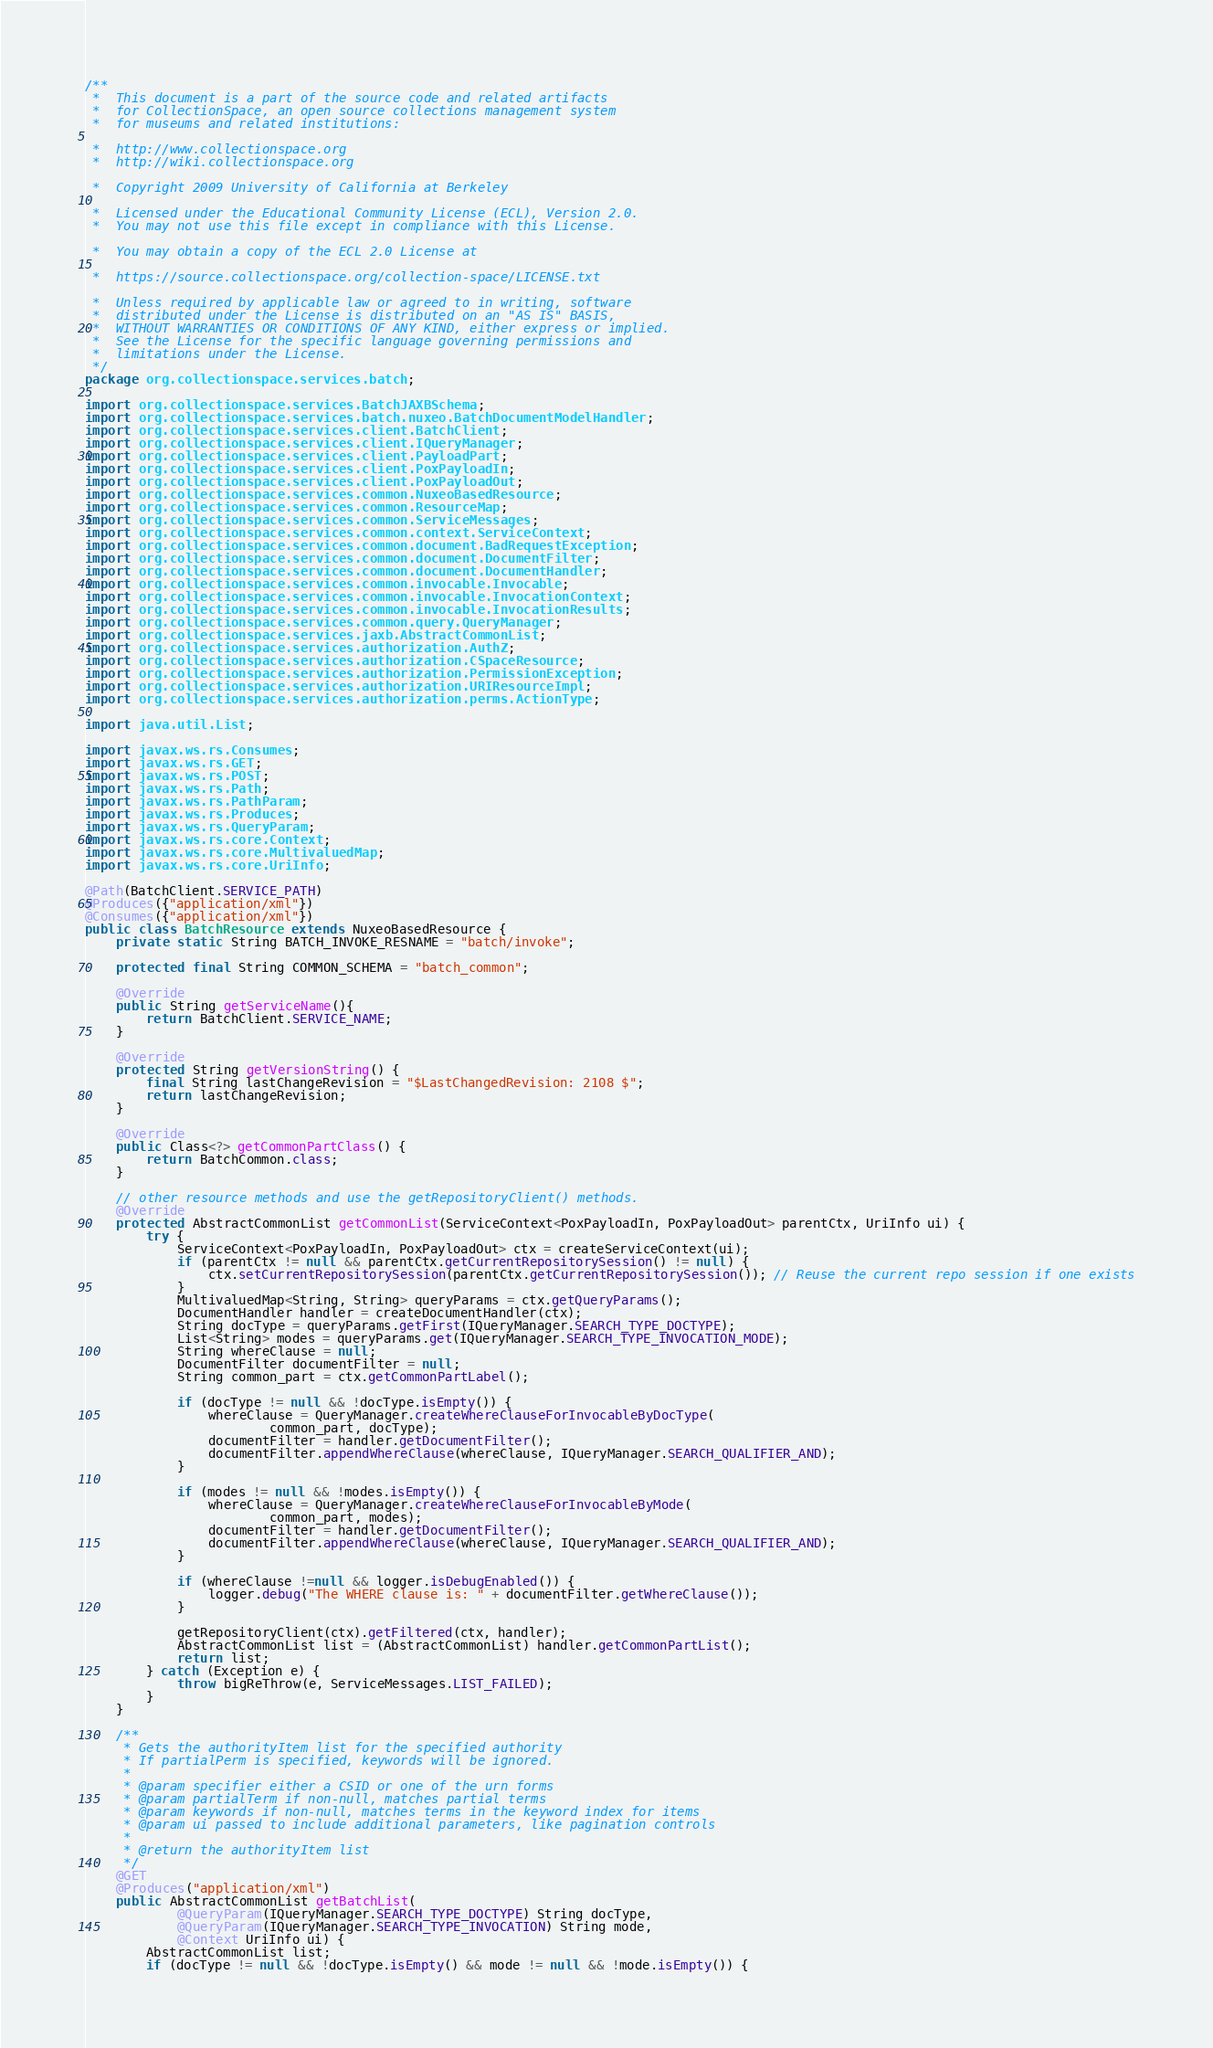Convert code to text. <code><loc_0><loc_0><loc_500><loc_500><_Java_>/**
 *  This document is a part of the source code and related artifacts
 *  for CollectionSpace, an open source collections management system
 *  for museums and related institutions:

 *  http://www.collectionspace.org
 *  http://wiki.collectionspace.org

 *  Copyright 2009 University of California at Berkeley

 *  Licensed under the Educational Community License (ECL), Version 2.0.
 *  You may not use this file except in compliance with this License.

 *  You may obtain a copy of the ECL 2.0 License at

 *  https://source.collectionspace.org/collection-space/LICENSE.txt

 *  Unless required by applicable law or agreed to in writing, software
 *  distributed under the License is distributed on an "AS IS" BASIS,
 *  WITHOUT WARRANTIES OR CONDITIONS OF ANY KIND, either express or implied.
 *  See the License for the specific language governing permissions and
 *  limitations under the License.
 */
package org.collectionspace.services.batch;

import org.collectionspace.services.BatchJAXBSchema;
import org.collectionspace.services.batch.nuxeo.BatchDocumentModelHandler;
import org.collectionspace.services.client.BatchClient;
import org.collectionspace.services.client.IQueryManager;
import org.collectionspace.services.client.PayloadPart;
import org.collectionspace.services.client.PoxPayloadIn;
import org.collectionspace.services.client.PoxPayloadOut;
import org.collectionspace.services.common.NuxeoBasedResource;
import org.collectionspace.services.common.ResourceMap;
import org.collectionspace.services.common.ServiceMessages;
import org.collectionspace.services.common.context.ServiceContext;
import org.collectionspace.services.common.document.BadRequestException;
import org.collectionspace.services.common.document.DocumentFilter;
import org.collectionspace.services.common.document.DocumentHandler;
import org.collectionspace.services.common.invocable.Invocable;
import org.collectionspace.services.common.invocable.InvocationContext;
import org.collectionspace.services.common.invocable.InvocationResults;
import org.collectionspace.services.common.query.QueryManager;
import org.collectionspace.services.jaxb.AbstractCommonList;
import org.collectionspace.services.authorization.AuthZ;
import org.collectionspace.services.authorization.CSpaceResource;
import org.collectionspace.services.authorization.PermissionException;
import org.collectionspace.services.authorization.URIResourceImpl;
import org.collectionspace.services.authorization.perms.ActionType;

import java.util.List;

import javax.ws.rs.Consumes;
import javax.ws.rs.GET;
import javax.ws.rs.POST;
import javax.ws.rs.Path;
import javax.ws.rs.PathParam;
import javax.ws.rs.Produces;
import javax.ws.rs.QueryParam;
import javax.ws.rs.core.Context;
import javax.ws.rs.core.MultivaluedMap;
import javax.ws.rs.core.UriInfo;

@Path(BatchClient.SERVICE_PATH)
@Produces({"application/xml"})
@Consumes({"application/xml"})
public class BatchResource extends NuxeoBasedResource {
    private static String BATCH_INVOKE_RESNAME = "batch/invoke";

	protected final String COMMON_SCHEMA = "batch_common";

    @Override
    public String getServiceName(){
        return BatchClient.SERVICE_NAME;
    }

    @Override
    protected String getVersionString() {
    	final String lastChangeRevision = "$LastChangedRevision: 2108 $";
    	return lastChangeRevision;
    }

    @Override
    public Class<?> getCommonPartClass() {
    	return BatchCommon.class;
    }

	// other resource methods and use the getRepositoryClient() methods.
	@Override
	protected AbstractCommonList getCommonList(ServiceContext<PoxPayloadIn, PoxPayloadOut> parentCtx, UriInfo ui) {
        try {
            ServiceContext<PoxPayloadIn, PoxPayloadOut> ctx = createServiceContext(ui);
            if (parentCtx != null && parentCtx.getCurrentRepositorySession() != null) {
                ctx.setCurrentRepositorySession(parentCtx.getCurrentRepositorySession()); // Reuse the current repo session if one exists
            }
            MultivaluedMap<String, String> queryParams = ctx.getQueryParams();
            DocumentHandler handler = createDocumentHandler(ctx);
            String docType = queryParams.getFirst(IQueryManager.SEARCH_TYPE_DOCTYPE);
            List<String> modes = queryParams.get(IQueryManager.SEARCH_TYPE_INVOCATION_MODE);
            String whereClause = null;
            DocumentFilter documentFilter = null;
            String common_part = ctx.getCommonPartLabel();

            if (docType != null && !docType.isEmpty()) {
                whereClause = QueryManager.createWhereClauseForInvocableByDocType(
                		common_part, docType);
                documentFilter = handler.getDocumentFilter();
                documentFilter.appendWhereClause(whereClause, IQueryManager.SEARCH_QUALIFIER_AND);
            }

            if (modes != null && !modes.isEmpty()) {
                whereClause = QueryManager.createWhereClauseForInvocableByMode(
                		common_part, modes);
                documentFilter = handler.getDocumentFilter();
                documentFilter.appendWhereClause(whereClause, IQueryManager.SEARCH_QUALIFIER_AND);
            }

            if (whereClause !=null && logger.isDebugEnabled()) {
                logger.debug("The WHERE clause is: " + documentFilter.getWhereClause());
            }

            getRepositoryClient(ctx).getFiltered(ctx, handler);
            AbstractCommonList list = (AbstractCommonList) handler.getCommonPartList();
            return list;
        } catch (Exception e) {
            throw bigReThrow(e, ServiceMessages.LIST_FAILED);
        }
    }

	/**
	 * Gets the authorityItem list for the specified authority
	 * If partialPerm is specified, keywords will be ignored.
	 *
	 * @param specifier either a CSID or one of the urn forms
	 * @param partialTerm if non-null, matches partial terms
	 * @param keywords if non-null, matches terms in the keyword index for items
	 * @param ui passed to include additional parameters, like pagination controls
	 *
	 * @return the authorityItem list
	 */
	@GET
	@Produces("application/xml")
	public AbstractCommonList getBatchList(
			@QueryParam(IQueryManager.SEARCH_TYPE_DOCTYPE) String docType,
			@QueryParam(IQueryManager.SEARCH_TYPE_INVOCATION) String mode,
			@Context UriInfo ui) {
        AbstractCommonList list;
        if (docType != null && !docType.isEmpty() && mode != null && !mode.isEmpty()) {</code> 